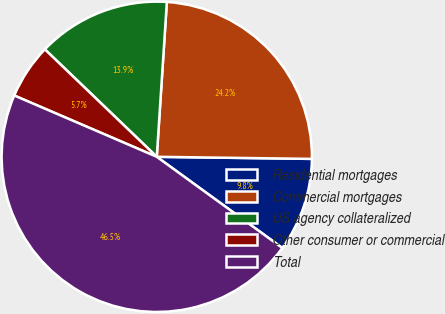<chart> <loc_0><loc_0><loc_500><loc_500><pie_chart><fcel>Residential mortgages<fcel>Commercial mortgages<fcel>US agency collateralized<fcel>Other consumer or commercial<fcel>Total<nl><fcel>9.78%<fcel>24.18%<fcel>13.86%<fcel>5.71%<fcel>46.47%<nl></chart> 